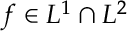Convert formula to latex. <formula><loc_0><loc_0><loc_500><loc_500>f \in L ^ { 1 } \cap L ^ { 2 }</formula> 